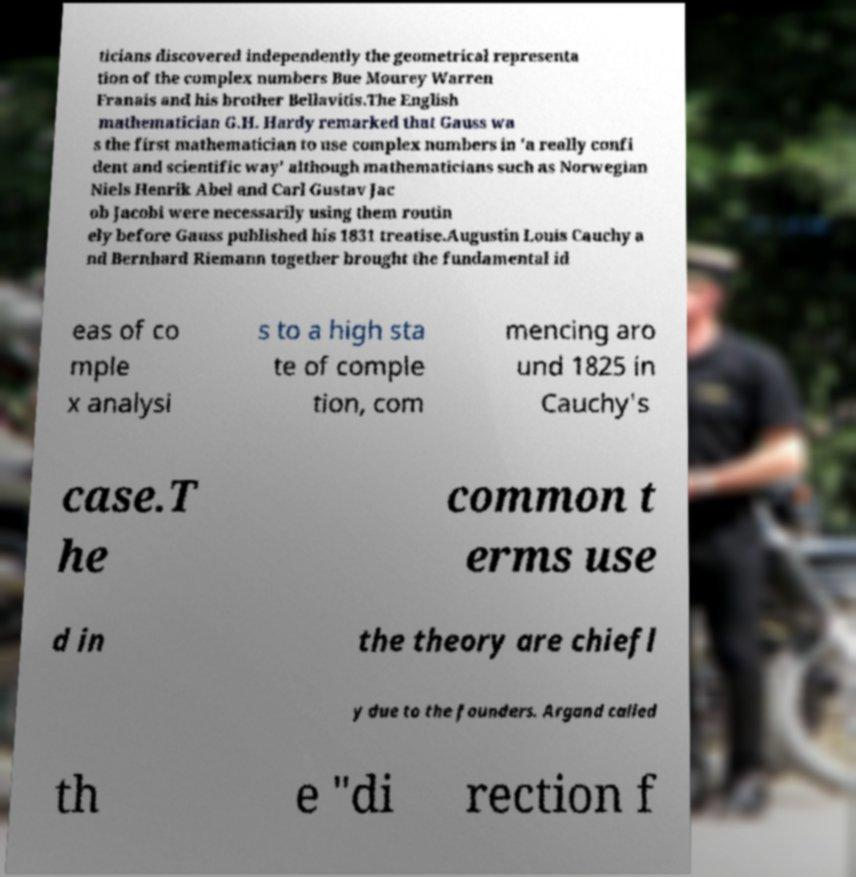There's text embedded in this image that I need extracted. Can you transcribe it verbatim? ticians discovered independently the geometrical representa tion of the complex numbers Bue Mourey Warren Franais and his brother Bellavitis.The English mathematician G.H. Hardy remarked that Gauss wa s the first mathematician to use complex numbers in 'a really confi dent and scientific way' although mathematicians such as Norwegian Niels Henrik Abel and Carl Gustav Jac ob Jacobi were necessarily using them routin ely before Gauss published his 1831 treatise.Augustin Louis Cauchy a nd Bernhard Riemann together brought the fundamental id eas of co mple x analysi s to a high sta te of comple tion, com mencing aro und 1825 in Cauchy's case.T he common t erms use d in the theory are chiefl y due to the founders. Argand called th e "di rection f 